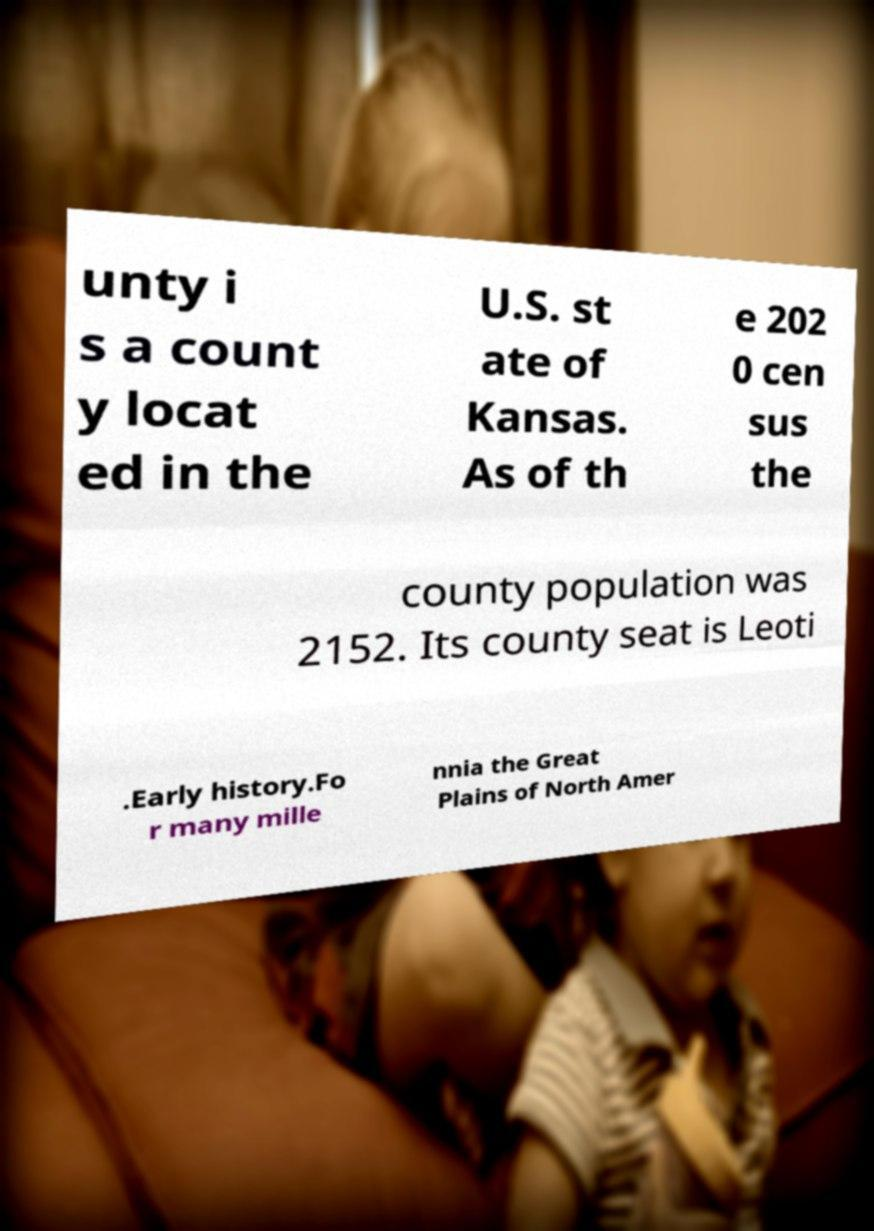There's text embedded in this image that I need extracted. Can you transcribe it verbatim? unty i s a count y locat ed in the U.S. st ate of Kansas. As of th e 202 0 cen sus the county population was 2152. Its county seat is Leoti .Early history.Fo r many mille nnia the Great Plains of North Amer 